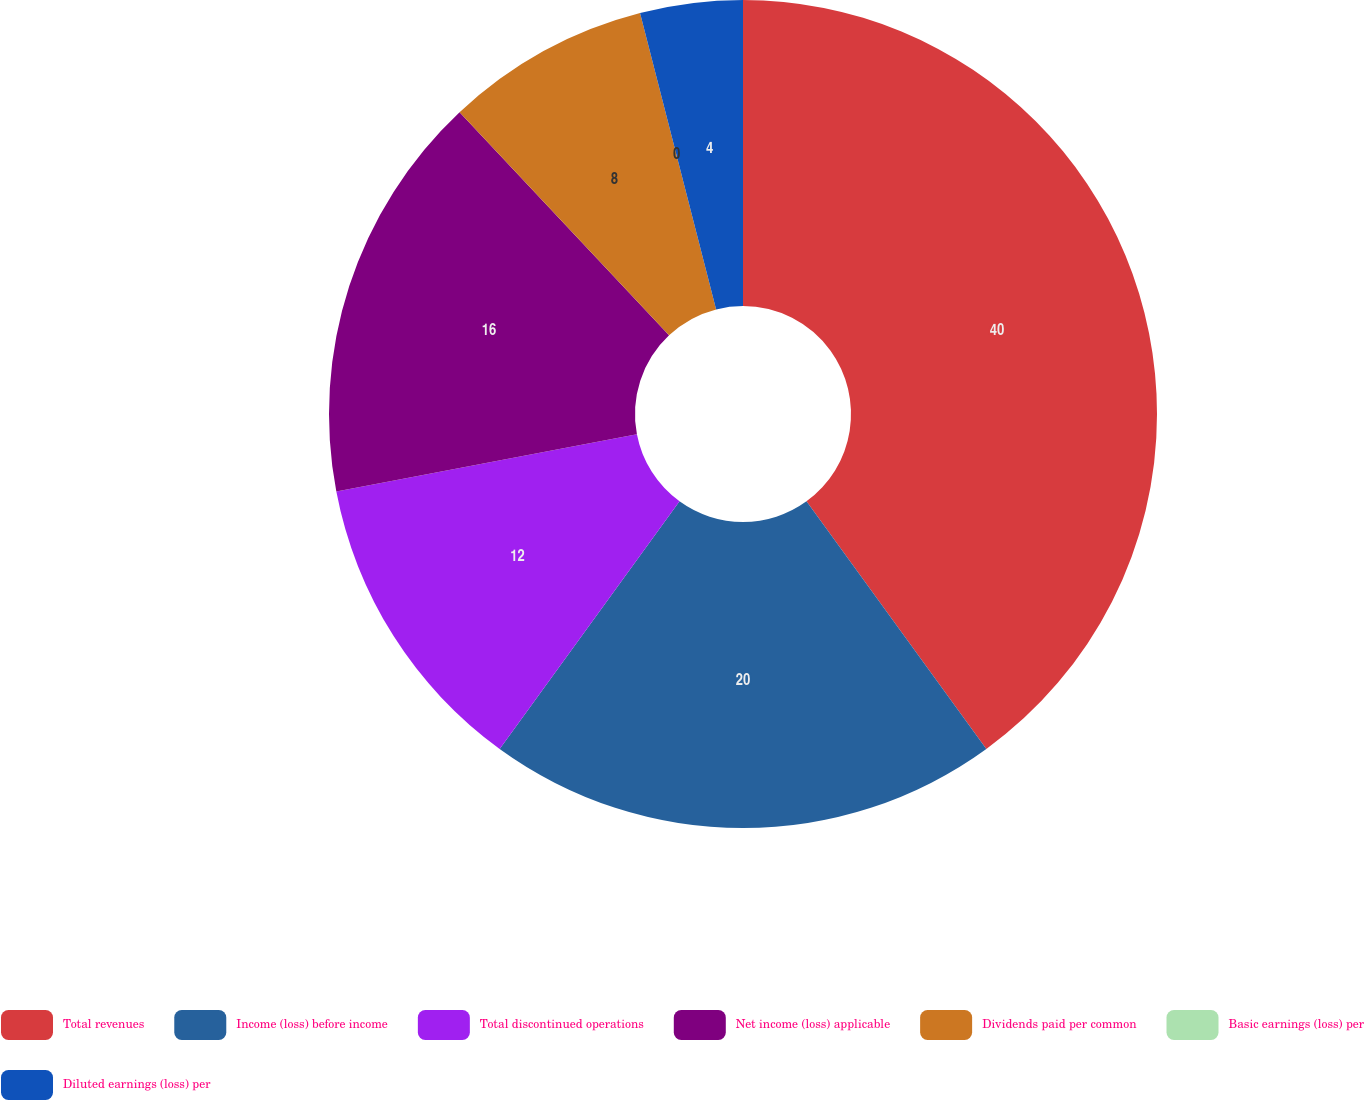<chart> <loc_0><loc_0><loc_500><loc_500><pie_chart><fcel>Total revenues<fcel>Income (loss) before income<fcel>Total discontinued operations<fcel>Net income (loss) applicable<fcel>Dividends paid per common<fcel>Basic earnings (loss) per<fcel>Diluted earnings (loss) per<nl><fcel>40.0%<fcel>20.0%<fcel>12.0%<fcel>16.0%<fcel>8.0%<fcel>0.0%<fcel>4.0%<nl></chart> 